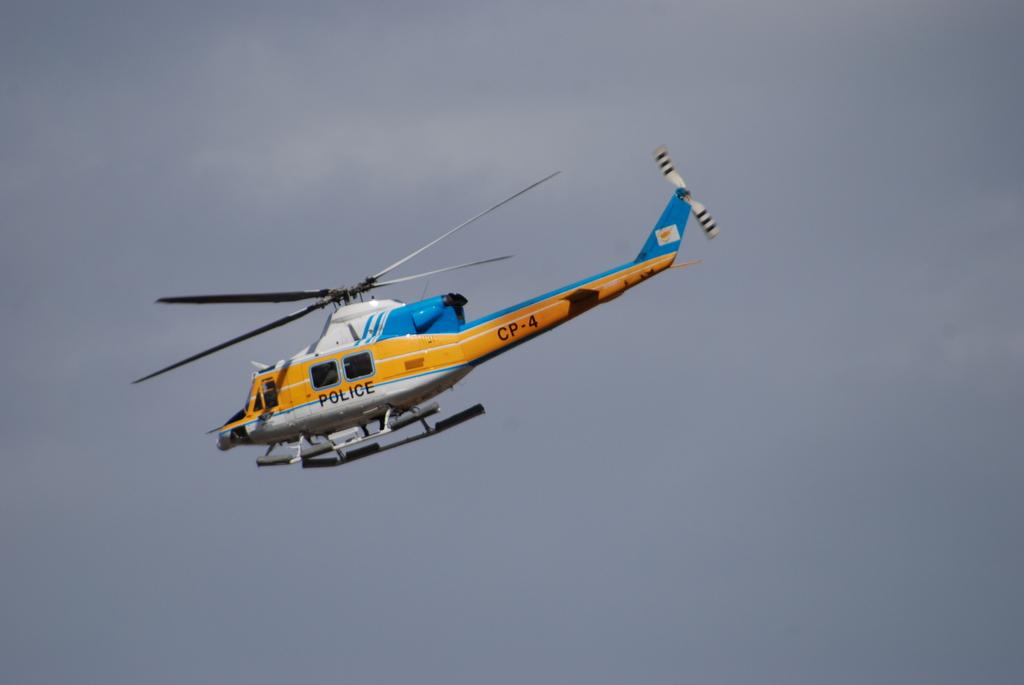What is the main subject of the image? The main subject of the image is a helicopter. What is the helicopter doing in the image? The helicopter is flying in the sky. Can you describe any additional details about the helicopter? Yes, there is text and a number written on the helicopter. How would you describe the weather in the image? The sky is cloudy in the image. Can you see any blood on the helicopter in the image? No, there is no blood visible on the helicopter in the image. Is there a bear accompanying the helicopter in the image? No, there is no bear present in the image. 